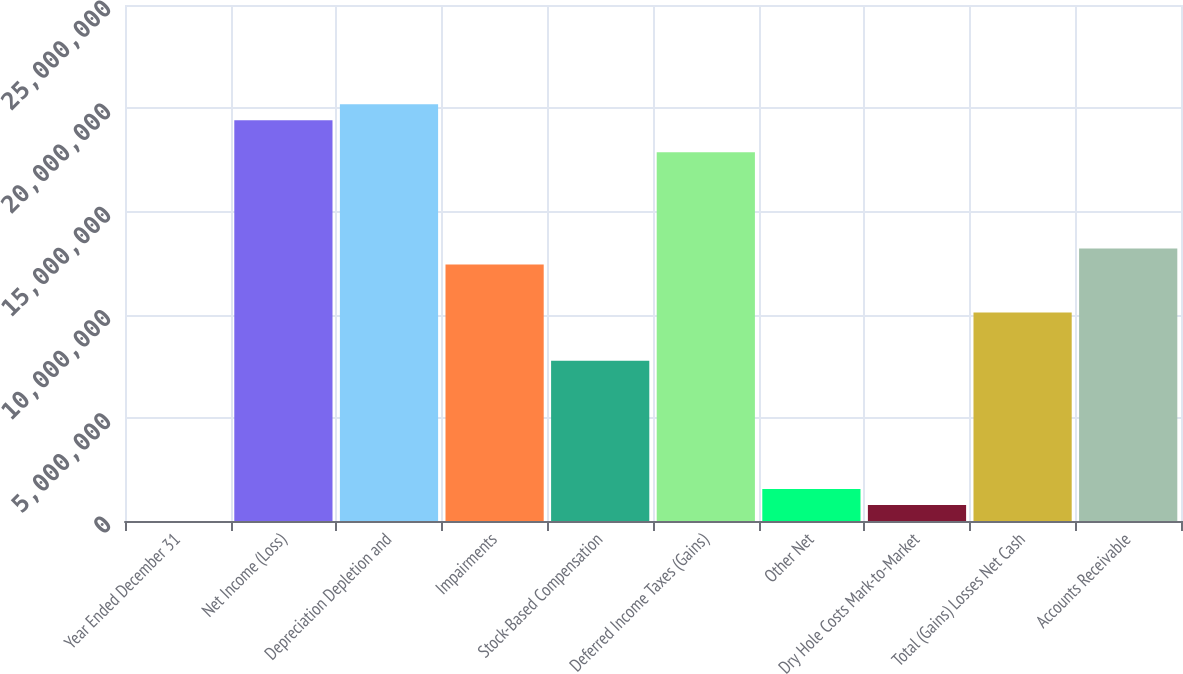<chart> <loc_0><loc_0><loc_500><loc_500><bar_chart><fcel>Year Ended December 31<fcel>Net Income (Loss)<fcel>Depreciation Depletion and<fcel>Impairments<fcel>Stock-Based Compensation<fcel>Deferred Income Taxes (Gains)<fcel>Other Net<fcel>Dry Hole Costs Mark-to-Market<fcel>Total (Gains) Losses Net Cash<fcel>Accounts Receivable<nl><fcel>2018<fcel>1.94185e+07<fcel>2.01952e+07<fcel>1.24286e+07<fcel>7.76861e+06<fcel>1.78652e+07<fcel>1.55534e+06<fcel>778677<fcel>1.00986e+07<fcel>1.32052e+07<nl></chart> 